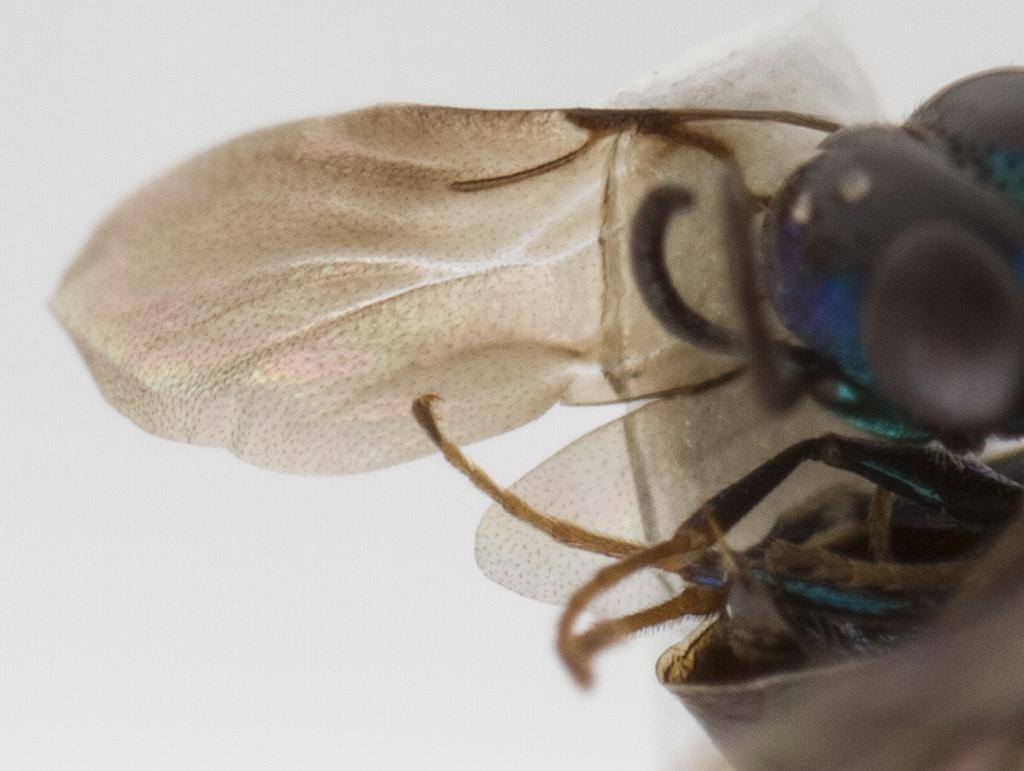What type of insects can be seen on the right side of the image? There are flies on the right side of the image. What color is the background of the image? The background of the image is white in color. How does the impulse affect the flies on the left side of the image? There are no flies on the left side of the image, and the concept of impulse is not relevant to the image. 